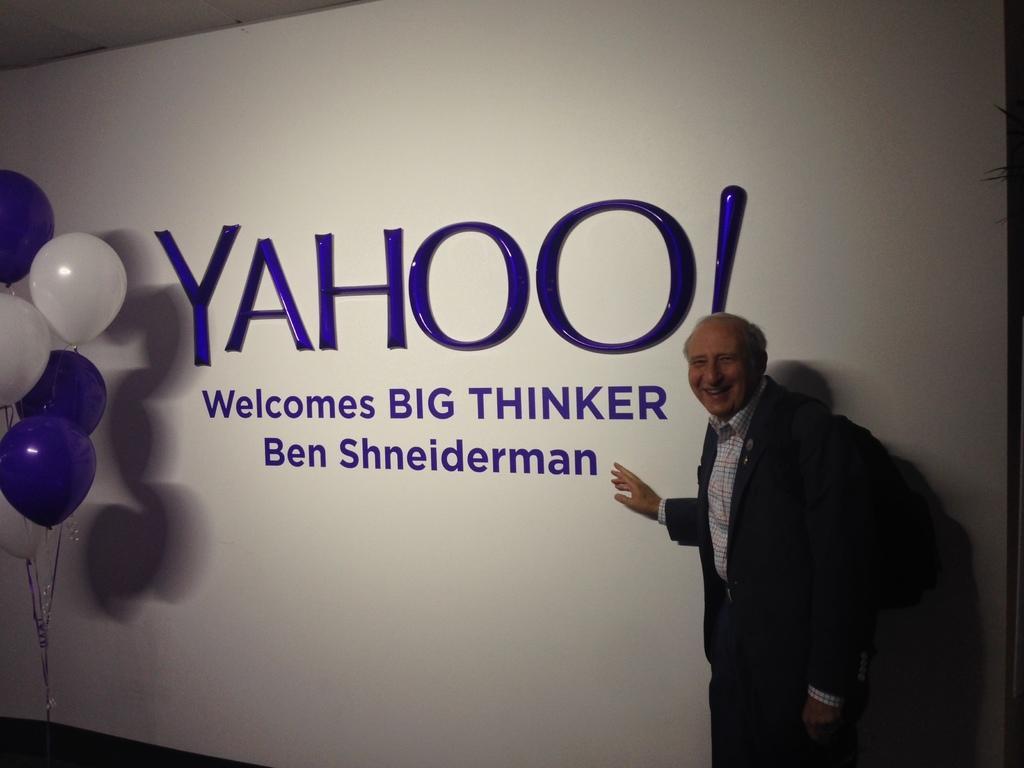Can you describe this image briefly? In this image, we can see old man is standing and smiling. He wore a backpack. Background we can see banner with some text. Left side of the image, few balloons with ribbons. 